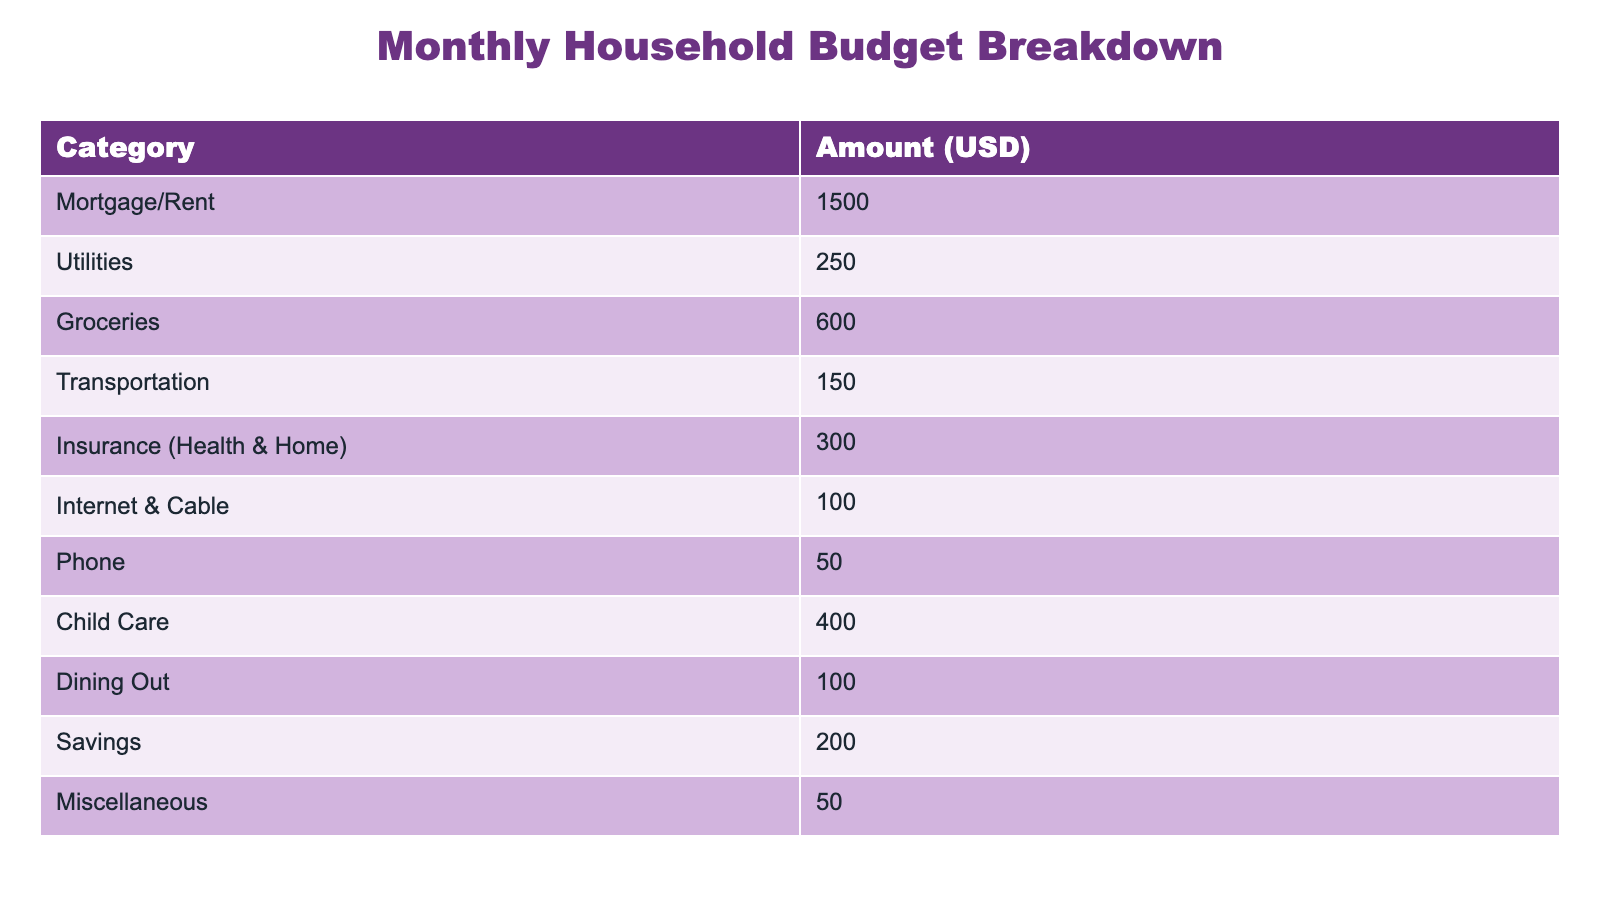What is the amount allocated for Groceries? The table shows that the amount listed under the "Groceries" category is $600.
Answer: 600 What is the total amount spent on Child Care and Dining Out? The amount spent on Child Care is $400 and Dining Out is $100. Adding these amounts together, 400 + 100 gives us $500.
Answer: 500 Is the amount for Utilities greater than that for Internet & Cable? The amount listed for Utilities is $250 and for Internet & Cable is $100. Since 250 is greater than 100, the statement is true.
Answer: Yes How much is allocated to Savings compared to Transportation? The amount for Savings is $200 and for Transportation it is $150. Since 200 is greater than 150, Savings is higher than Transportation.
Answer: Yes What is the total monthly budget? To find the total monthly budget, we need to sum all the amounts in the table: 1500 + 250 + 600 + 150 + 300 + 100 + 50 + 400 + 100 + 200 + 50 = $3600.
Answer: 3600 What percentage of the total budget is spent on Insurance (Health & Home)? The amount for Insurance is $300. First, we found the total budget is $3600. Next, we calculate the percentage as (300 / 3600) * 100, which equals approximately 8.33%.
Answer: 8.33% Which category has the smallest budget allocation? By reviewing the amounts in the table, the "Phone" category has the smallest allocation of $50.
Answer: Phone What is the total for all expenses excluding Savings and Miscellaneous? The total amount excluding Savings ($200) and Miscellaneous ($50) means we need to add the remaining categories: 1500 + 250 + 600 + 150 + 300 + 100 + 50 + 400 + 100 = $3000.
Answer: 3000 Are the combined amounts for Mortgage/Rent and Insurance less than the combined amounts for Groceries and Child Care? The combined amount for Mortgage/Rent ($1500) and Insurance ($300) is $1800, while Groceries ($600) and Child Care ($400) combine to $1000. Since 1800 is greater than 1000, the answer is no.
Answer: No 